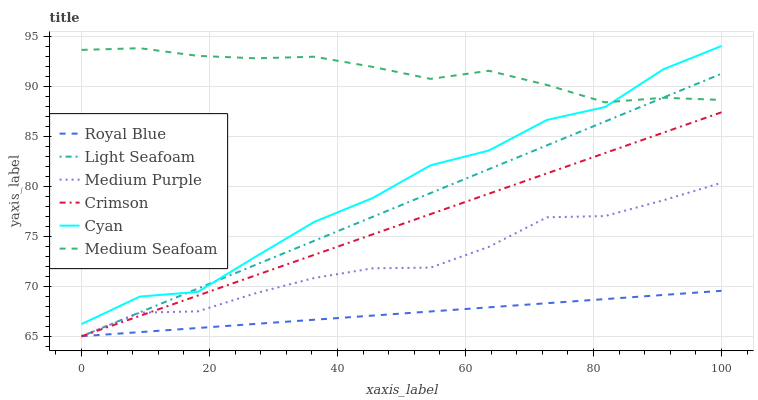Does Royal Blue have the minimum area under the curve?
Answer yes or no. Yes. Does Medium Seafoam have the maximum area under the curve?
Answer yes or no. Yes. Does Crimson have the minimum area under the curve?
Answer yes or no. No. Does Crimson have the maximum area under the curve?
Answer yes or no. No. Is Crimson the smoothest?
Answer yes or no. Yes. Is Cyan the roughest?
Answer yes or no. Yes. Is Royal Blue the smoothest?
Answer yes or no. No. Is Royal Blue the roughest?
Answer yes or no. No. Does Medium Purple have the lowest value?
Answer yes or no. Yes. Does Cyan have the lowest value?
Answer yes or no. No. Does Cyan have the highest value?
Answer yes or no. Yes. Does Crimson have the highest value?
Answer yes or no. No. Is Medium Purple less than Cyan?
Answer yes or no. Yes. Is Cyan greater than Royal Blue?
Answer yes or no. Yes. Does Light Seafoam intersect Royal Blue?
Answer yes or no. Yes. Is Light Seafoam less than Royal Blue?
Answer yes or no. No. Is Light Seafoam greater than Royal Blue?
Answer yes or no. No. Does Medium Purple intersect Cyan?
Answer yes or no. No. 